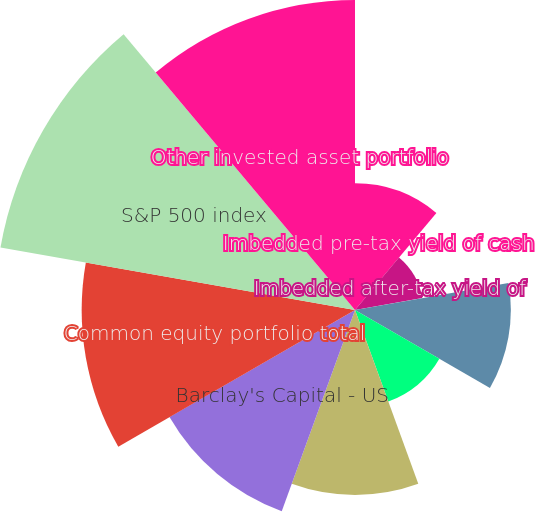<chart> <loc_0><loc_0><loc_500><loc_500><pie_chart><fcel>Imbedded pre-tax yield of cash<fcel>Imbedded after-tax yield of<fcel>Annualized pre-tax yield on<fcel>Annualized after-tax yield on<fcel>Fixed income portfolio total<fcel>Barclay's Capital - US<fcel>Common equity portfolio total<fcel>S&P 500 index<fcel>Other invested asset portfolio<nl><fcel>7.07%<fcel>3.82%<fcel>8.7%<fcel>5.44%<fcel>10.33%<fcel>11.96%<fcel>15.26%<fcel>20.1%<fcel>17.31%<nl></chart> 